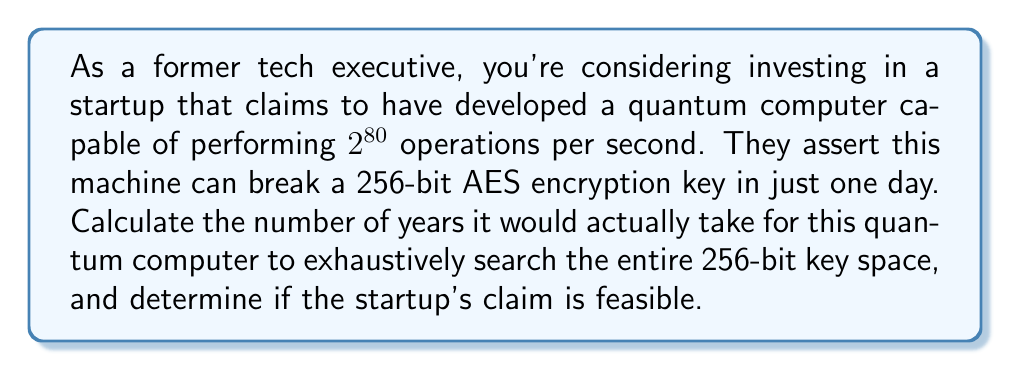Could you help me with this problem? Let's approach this step-by-step:

1) First, we need to calculate the size of the 256-bit key space:
   $$2^{256}$$ possible keys

2) The quantum computer can perform $2^{80}$ operations per second.
   In one day, it can perform:
   $$2^{80} \cdot 60 \cdot 60 \cdot 24 = 2^{80} \cdot 86400$$ operations

3) To find the time needed to search the entire key space, we divide the number of possible keys by the operations per day:

   $$\text{Days required} = \frac{2^{256}}{2^{80} \cdot 86400}$$

4) Simplify:
   $$\frac{2^{256}}{2^{80} \cdot 86400} = \frac{2^{176}}{86400}$$

5) Calculate:
   $$\frac{2^{176}}{86400} \approx 1.37 \cdot 10^{48} \text{ days}$$

6) Convert to years:
   $$\frac{1.37 \cdot 10^{48}}{365} \approx 3.75 \cdot 10^{45} \text{ years}$$

7) This is significantly longer than the age of the universe (approximately $13.8 \cdot 10^9$ years), making the startup's claim infeasible.
Answer: $3.75 \cdot 10^{45}$ years; claim infeasible 